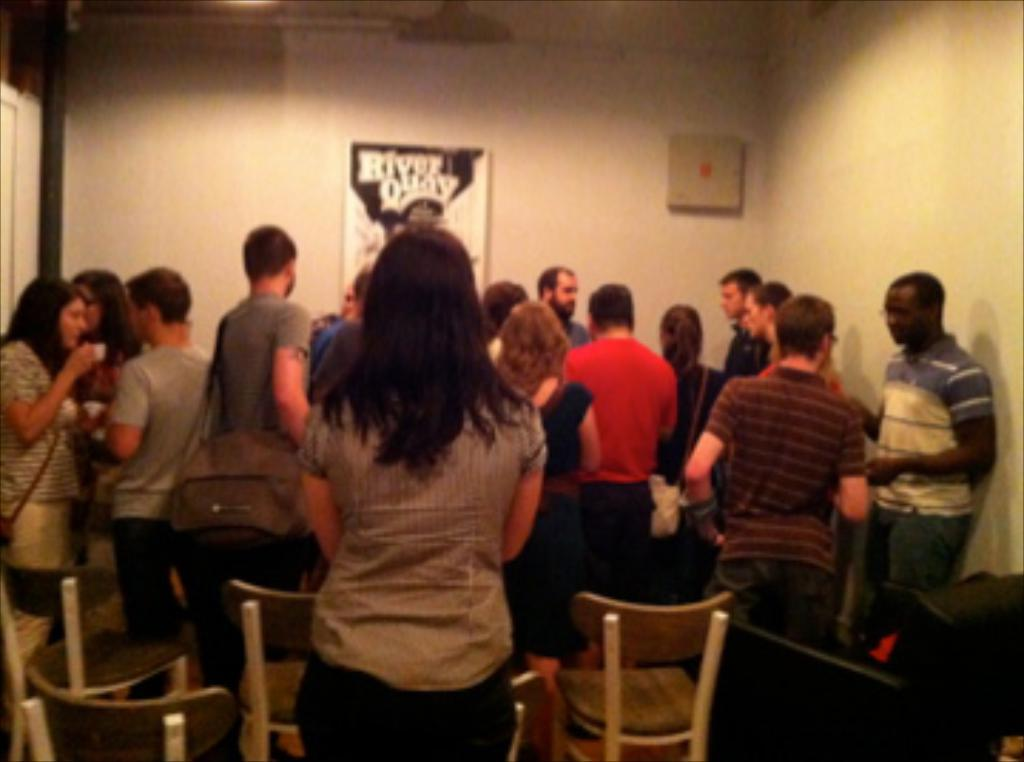What is happening in the room in the image? There are people standing in the room. What type of furniture is present in the room? There are chairs in the room. What can be seen on the wall in the image? There is a poster on the wall. What is the purpose of the trucks in the image? There are no trucks present in the image. 